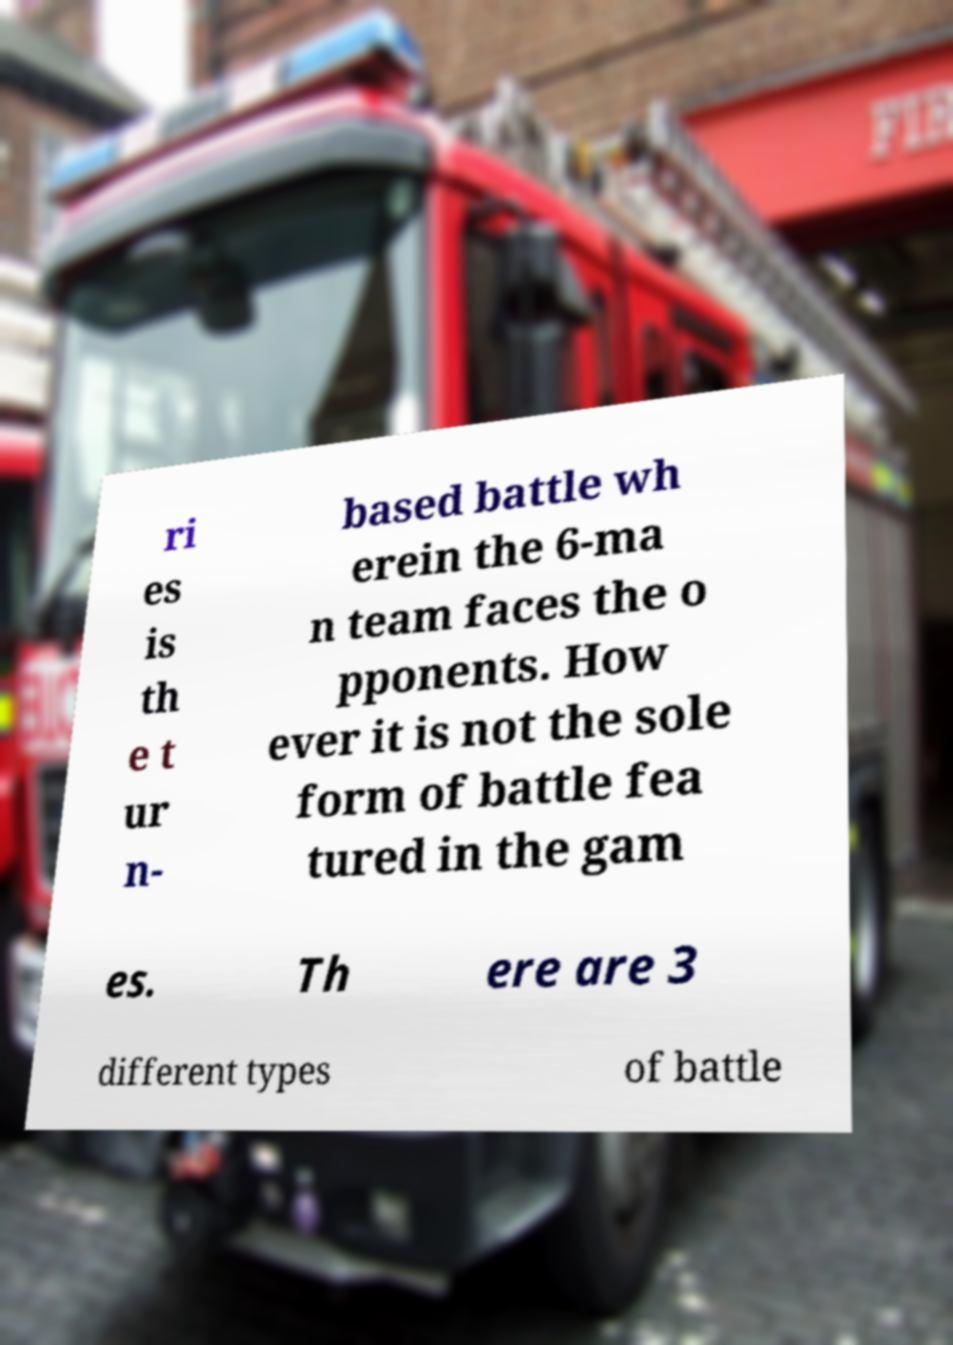For documentation purposes, I need the text within this image transcribed. Could you provide that? ri es is th e t ur n- based battle wh erein the 6-ma n team faces the o pponents. How ever it is not the sole form of battle fea tured in the gam es. Th ere are 3 different types of battle 